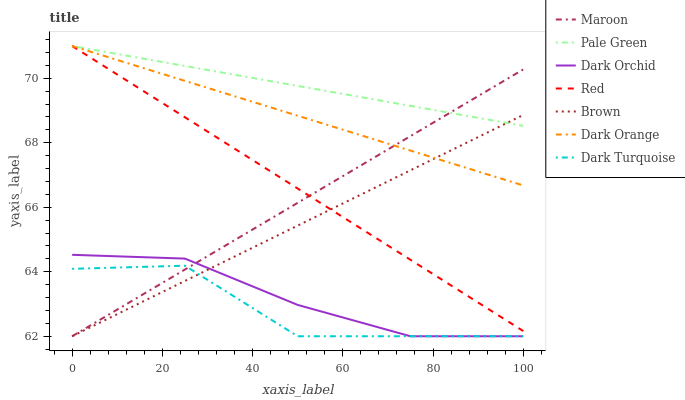Does Dark Turquoise have the minimum area under the curve?
Answer yes or no. Yes. Does Pale Green have the maximum area under the curve?
Answer yes or no. Yes. Does Brown have the minimum area under the curve?
Answer yes or no. No. Does Brown have the maximum area under the curve?
Answer yes or no. No. Is Red the smoothest?
Answer yes or no. Yes. Is Dark Turquoise the roughest?
Answer yes or no. Yes. Is Brown the smoothest?
Answer yes or no. No. Is Brown the roughest?
Answer yes or no. No. Does Brown have the lowest value?
Answer yes or no. Yes. Does Pale Green have the lowest value?
Answer yes or no. No. Does Red have the highest value?
Answer yes or no. Yes. Does Brown have the highest value?
Answer yes or no. No. Is Dark Orchid less than Dark Orange?
Answer yes or no. Yes. Is Red greater than Dark Orchid?
Answer yes or no. Yes. Does Red intersect Brown?
Answer yes or no. Yes. Is Red less than Brown?
Answer yes or no. No. Is Red greater than Brown?
Answer yes or no. No. Does Dark Orchid intersect Dark Orange?
Answer yes or no. No. 